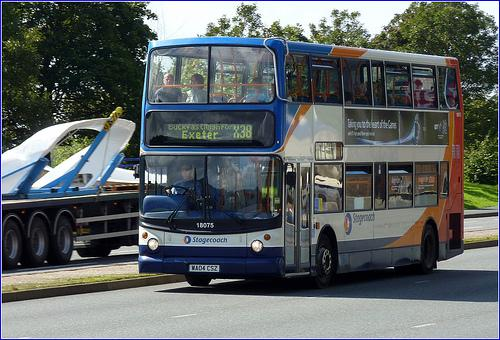Question: what is this?
Choices:
A. A bike.
B. A bus.
C. A car.
D. A truck.
Answer with the letter. Answer: B Question: how many wheels does this bus have?
Choices:
A. Five.
B. Eight.
C. Nine.
D. Four.
Answer with the letter. Answer: D Question: where is this bus?
Choices:
A. On the road.
B. In the parking lot.
C. On the highway.
D. At the bus station.
Answer with the letter. Answer: A Question: when was the picture taken?
Choices:
A. During the night.
B. During the day.
C. During the evening.
D. During the rain storm.
Answer with the letter. Answer: B Question: what side of the bus is the door on?
Choices:
A. Right side.
B. Left side.
C. Driver's side.
D. Passenger's side.
Answer with the letter. Answer: B 